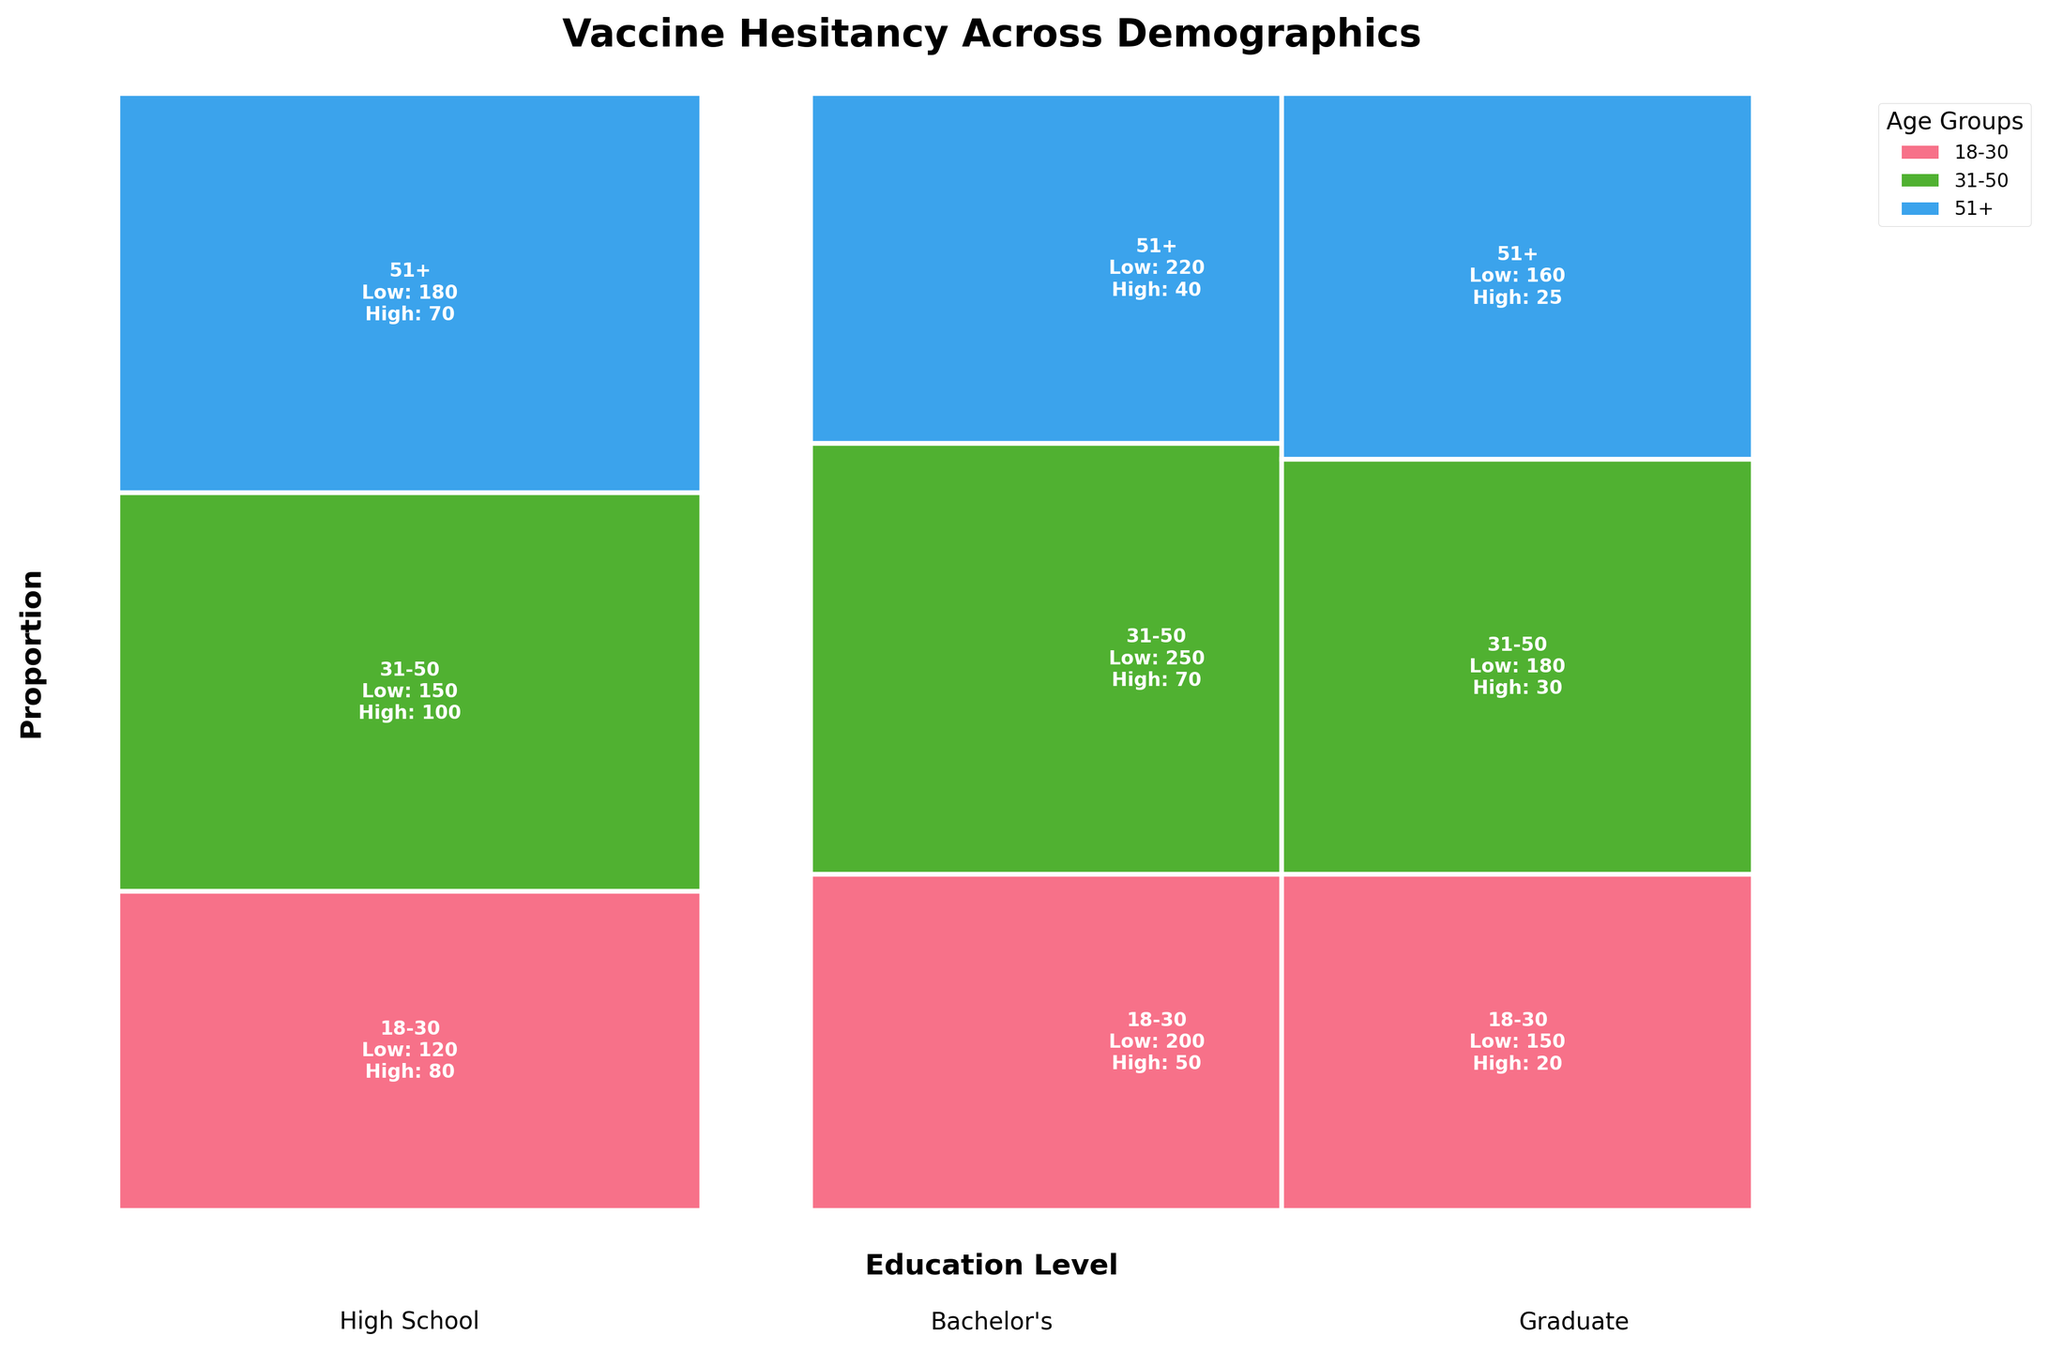What is the total number of age groups shown in the figure? The figure legend shows the number of age groups represented by different colors.
Answer: 3 Which age group has the lowest vaccine hesitancy in the Bachelor's category? In the Bachelor's category, locate the rectangles labeled by age groups, then compare the "High" values. The one with the lowest value is the group with the lowest hesitancy.
Answer: 51+ How does vaccine hesitancy for individuals with a High School education compare between the 18-30 and 31-50 age groups? Locate the "High School" category. Compare the vaccine hesitancy counts labeled "High" for the 18-30 and 31-50 age groups.
Answer: 18-30 is higher What is the proportion of the "Low" vaccine hesitancy response for Bachelor's degree holders aged 31-50? Find the rectangle for Bachelor's degree holders aged 31-50, and note the "Low" and "High" values. Calculate the proportion of "Low" (Low / (Low + High)).
Answer: 250 / (250 + 70) Which demographic group shows the highest overall vaccine hesitancy? Compare the "High" counts across all rectangles for each education level and age group. The demographic with the highest number in "High" is the group with the highest hesitancy.
Answer: High School, 31-50 Among the Graduate degree holders, in which age group is vaccine hesitancy the highest? Find the "Graduate" category, and compare the "High" hesitancy counts for each age group. Identify the age group with the highest number.
Answer: 31-50 What education level has the lowest overall vaccine hesitancy in the 51+ age group? Investigate the "51+" rectangles for each education level, and compare the "High" hesitancy counts to determine the lowest.
Answer: Graduate Considering all age groups, which education level shows the highest total low vaccine hesitancy? Sum the counts of "Low" hesitancy across all age groups within each education level, and compare the totals to find the highest.
Answer: Bachelor's What is the difference in vaccine hesitancy between Bachelor's and High School graduates aged 18-30? Subtract the "High" hesitancy count of Bachelor's degree holders from the "High" hesitancy count of High School graduates in the 18-30 age group.
Answer: 80 - 50 = 30 Which education level has a wider range of hesitancy within the 31-50 age group? Compare the difference between 'Low' and 'High' counts within the 31-50 age group for each education level.
Answer: High School 